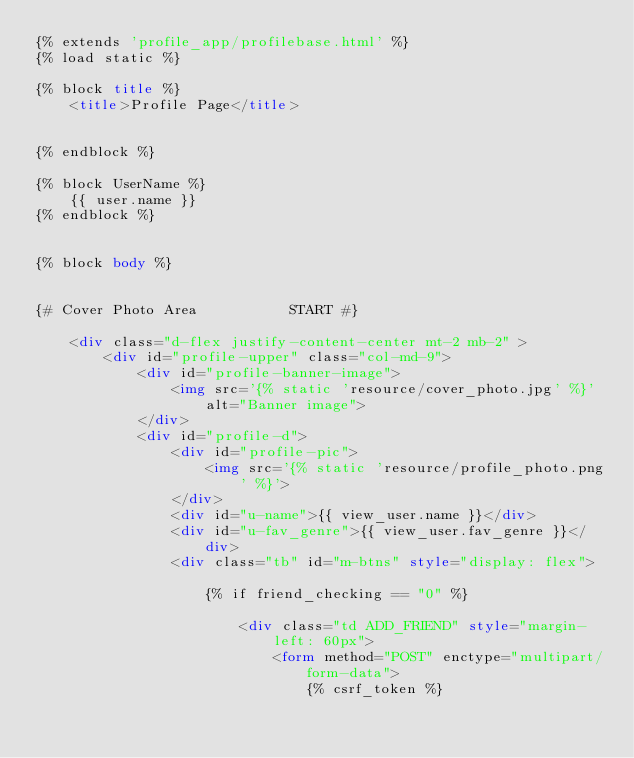Convert code to text. <code><loc_0><loc_0><loc_500><loc_500><_HTML_>{% extends 'profile_app/profilebase.html' %}
{% load static %}

{% block title %}
    <title>Profile Page</title>


{% endblock %}

{% block UserName %}
    {{ user.name }}
{% endblock %}


{% block body %}


{# Cover Photo Area           START #}

    <div class="d-flex justify-content-center mt-2 mb-2" >
        <div id="profile-upper" class="col-md-9">
            <div id="profile-banner-image">
                <img src='{% static 'resource/cover_photo.jpg' %}' alt="Banner image">
            </div>
            <div id="profile-d">
                <div id="profile-pic">
                    <img src='{% static 'resource/profile_photo.png' %}'>
                </div>
                <div id="u-name">{{ view_user.name }}</div>
                <div id="u-fav_genre">{{ view_user.fav_genre }}</div>
                <div class="tb" id="m-btns" style="display: flex">

                    {% if friend_checking == "0" %}

                        <div class="td ADD_FRIEND" style="margin-left: 60px">
                            <form method="POST" enctype="multipart/form-data">
                                {% csrf_token %}</code> 